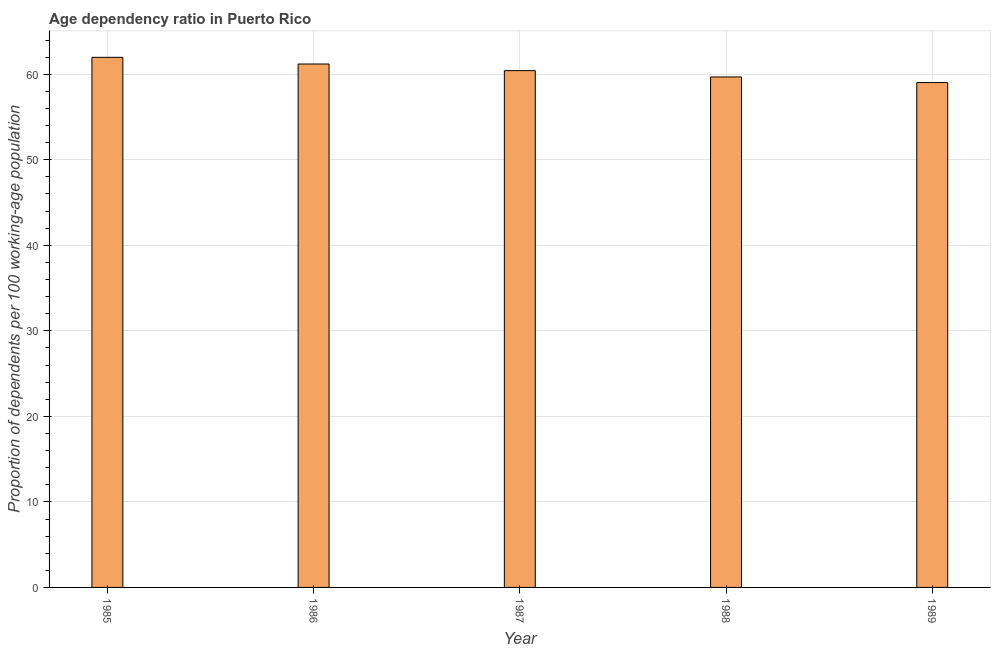Does the graph contain any zero values?
Make the answer very short. No. Does the graph contain grids?
Provide a short and direct response. Yes. What is the title of the graph?
Provide a short and direct response. Age dependency ratio in Puerto Rico. What is the label or title of the Y-axis?
Offer a very short reply. Proportion of dependents per 100 working-age population. What is the age dependency ratio in 1988?
Make the answer very short. 59.68. Across all years, what is the maximum age dependency ratio?
Offer a very short reply. 61.98. Across all years, what is the minimum age dependency ratio?
Keep it short and to the point. 59.03. What is the sum of the age dependency ratio?
Make the answer very short. 302.31. What is the difference between the age dependency ratio in 1988 and 1989?
Your answer should be very brief. 0.65. What is the average age dependency ratio per year?
Provide a short and direct response. 60.46. What is the median age dependency ratio?
Make the answer very short. 60.42. Do a majority of the years between 1987 and 1985 (inclusive) have age dependency ratio greater than 18 ?
Offer a very short reply. Yes. Is the age dependency ratio in 1985 less than that in 1987?
Ensure brevity in your answer.  No. What is the difference between the highest and the second highest age dependency ratio?
Keep it short and to the point. 0.78. What is the difference between the highest and the lowest age dependency ratio?
Give a very brief answer. 2.95. In how many years, is the age dependency ratio greater than the average age dependency ratio taken over all years?
Your answer should be compact. 2. How many bars are there?
Ensure brevity in your answer.  5. Are the values on the major ticks of Y-axis written in scientific E-notation?
Your answer should be very brief. No. What is the Proportion of dependents per 100 working-age population in 1985?
Your answer should be very brief. 61.98. What is the Proportion of dependents per 100 working-age population of 1986?
Ensure brevity in your answer.  61.2. What is the Proportion of dependents per 100 working-age population of 1987?
Offer a very short reply. 60.42. What is the Proportion of dependents per 100 working-age population of 1988?
Provide a short and direct response. 59.68. What is the Proportion of dependents per 100 working-age population in 1989?
Offer a terse response. 59.03. What is the difference between the Proportion of dependents per 100 working-age population in 1985 and 1986?
Your answer should be compact. 0.78. What is the difference between the Proportion of dependents per 100 working-age population in 1985 and 1987?
Keep it short and to the point. 1.56. What is the difference between the Proportion of dependents per 100 working-age population in 1985 and 1988?
Make the answer very short. 2.3. What is the difference between the Proportion of dependents per 100 working-age population in 1985 and 1989?
Provide a short and direct response. 2.95. What is the difference between the Proportion of dependents per 100 working-age population in 1986 and 1987?
Provide a short and direct response. 0.78. What is the difference between the Proportion of dependents per 100 working-age population in 1986 and 1988?
Keep it short and to the point. 1.52. What is the difference between the Proportion of dependents per 100 working-age population in 1986 and 1989?
Make the answer very short. 2.17. What is the difference between the Proportion of dependents per 100 working-age population in 1987 and 1988?
Ensure brevity in your answer.  0.74. What is the difference between the Proportion of dependents per 100 working-age population in 1987 and 1989?
Provide a short and direct response. 1.39. What is the difference between the Proportion of dependents per 100 working-age population in 1988 and 1989?
Ensure brevity in your answer.  0.65. What is the ratio of the Proportion of dependents per 100 working-age population in 1985 to that in 1988?
Offer a very short reply. 1.04. What is the ratio of the Proportion of dependents per 100 working-age population in 1985 to that in 1989?
Your answer should be very brief. 1.05. What is the ratio of the Proportion of dependents per 100 working-age population in 1987 to that in 1989?
Your answer should be very brief. 1.02. What is the ratio of the Proportion of dependents per 100 working-age population in 1988 to that in 1989?
Offer a terse response. 1.01. 